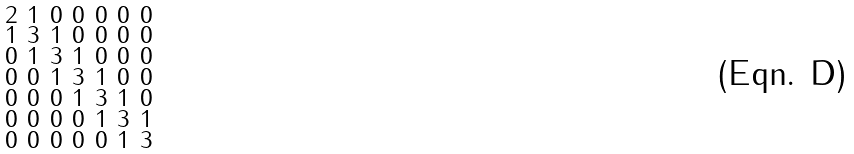<formula> <loc_0><loc_0><loc_500><loc_500>\begin{smallmatrix} 2 & 1 & 0 & 0 & 0 & 0 & 0 \\ 1 & 3 & 1 & 0 & 0 & 0 & 0 \\ 0 & 1 & 3 & 1 & 0 & 0 & 0 \\ 0 & 0 & 1 & 3 & 1 & 0 & 0 \\ 0 & 0 & 0 & 1 & 3 & 1 & 0 \\ 0 & 0 & 0 & 0 & 1 & 3 & 1 \\ 0 & 0 & 0 & 0 & 0 & 1 & 3 \end{smallmatrix}</formula> 